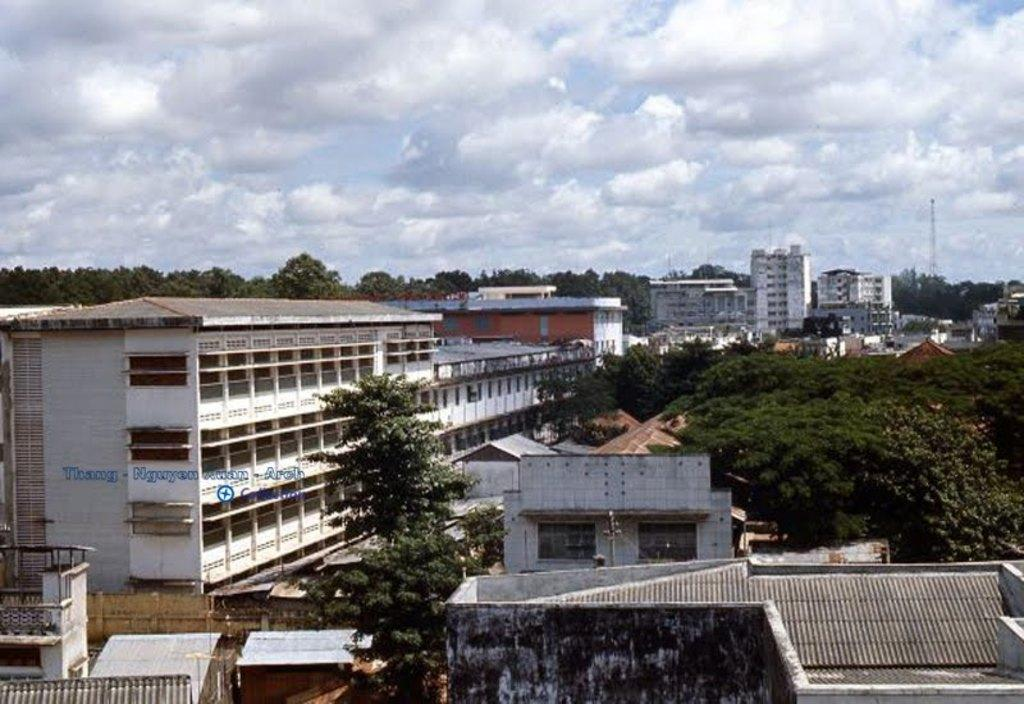What type of structures can be seen in the image? There are many buildings in the image. What other natural elements are present in the image? There are trees in the image. Can you describe the tower visible in the background? There is a tower visible in the background. How many trees can be seen in the background? There are more trees in the background. What can be seen in the sky in the background? Clouds and the sky are visible in the background. What type of event is being approved in the image? There is no event or approval process depicted in the image; it primarily features buildings, trees, and a tower. 